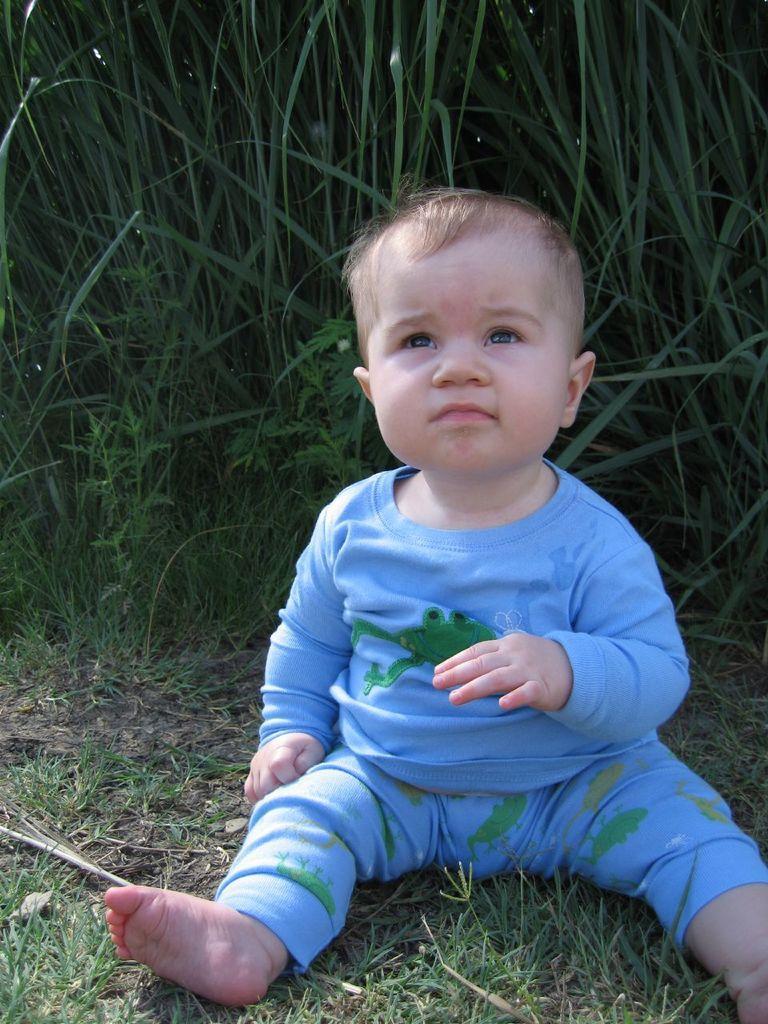Please provide a concise description of this image. In this image I can see a baby in blue dress. I can also see grass and plants. 